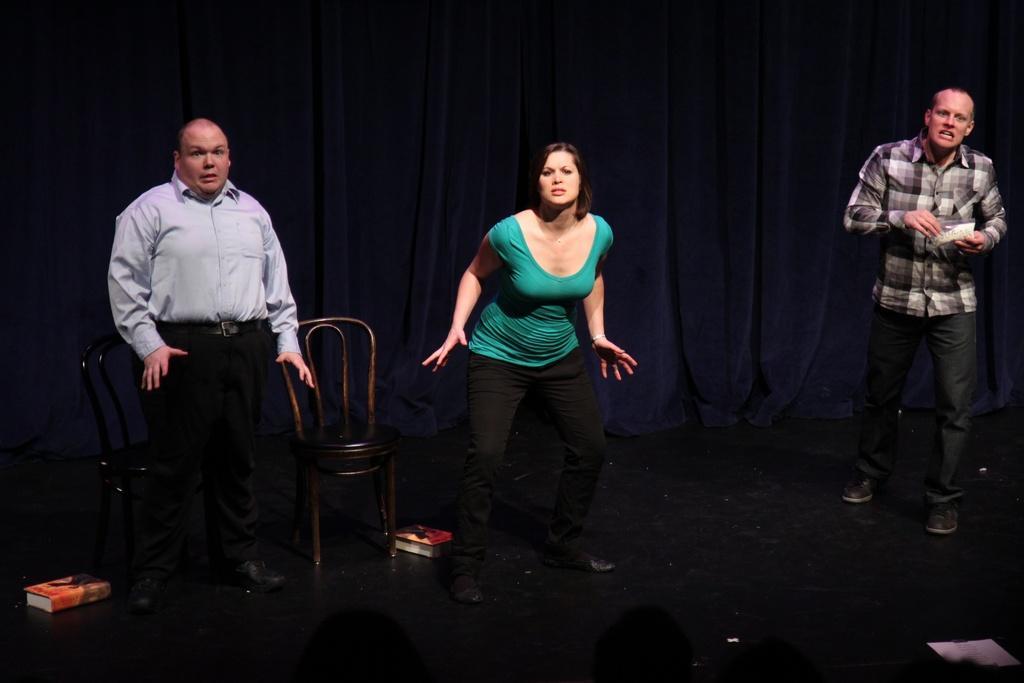Describe this image in one or two sentences. There are three members standing on the floor in this picture. Two of them were men and the middle one is a woman. There is a chair. In the background, we can observe curtain. 